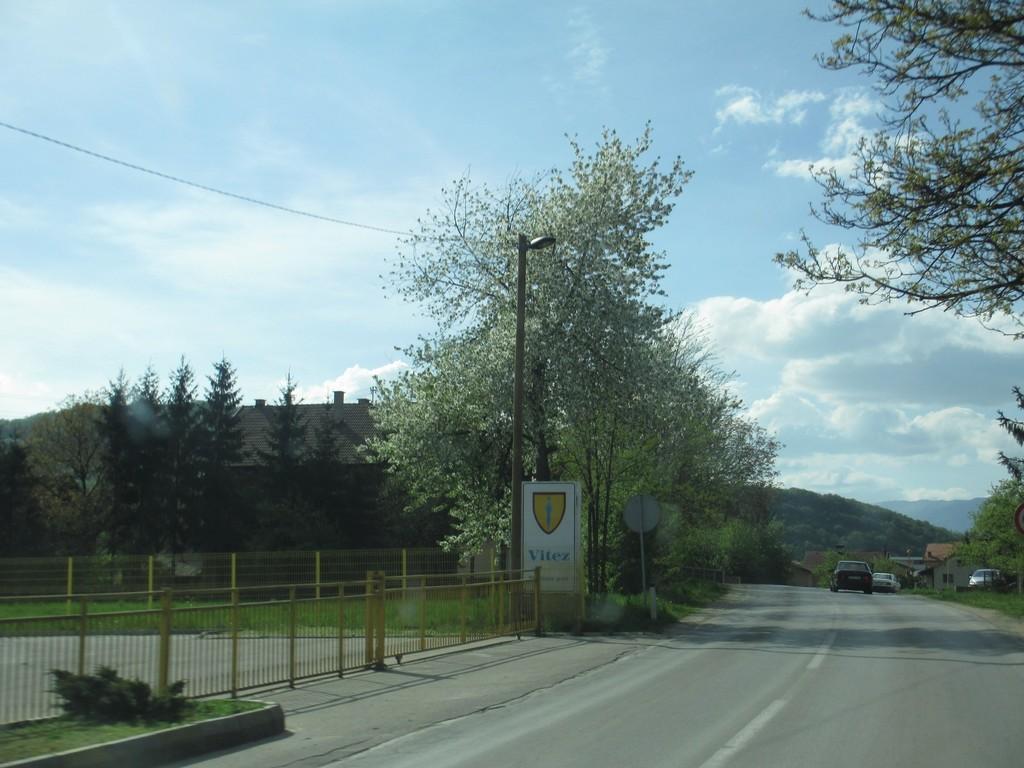Please provide a concise description of this image. This a picture of a outdoor. Here we can see on the road there are two cars one in black color and other is in white color there is other car which is in parking and there are houses near to the car and also shed behind behind the tree. This is a tree front of the tree there is a pole with a street light and here is a board signing vitex and this a gate which is colored yellow color. And background of the tree and the shed this is sky without clouds. 